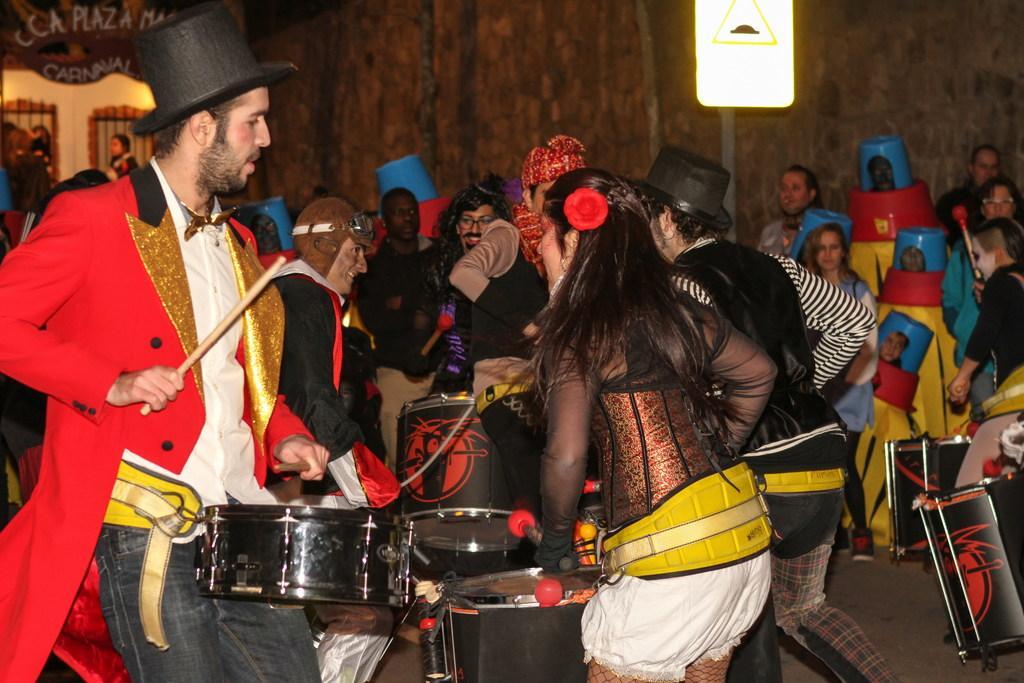In one or two sentences, can you explain what this image depicts? In this image, there is an inside view of a building. There are some persons wearing clothes and playing musical drums. There is a wall behind these persons. There is a person on the left of the image wearing cap. There is a board in the top right of the image. 